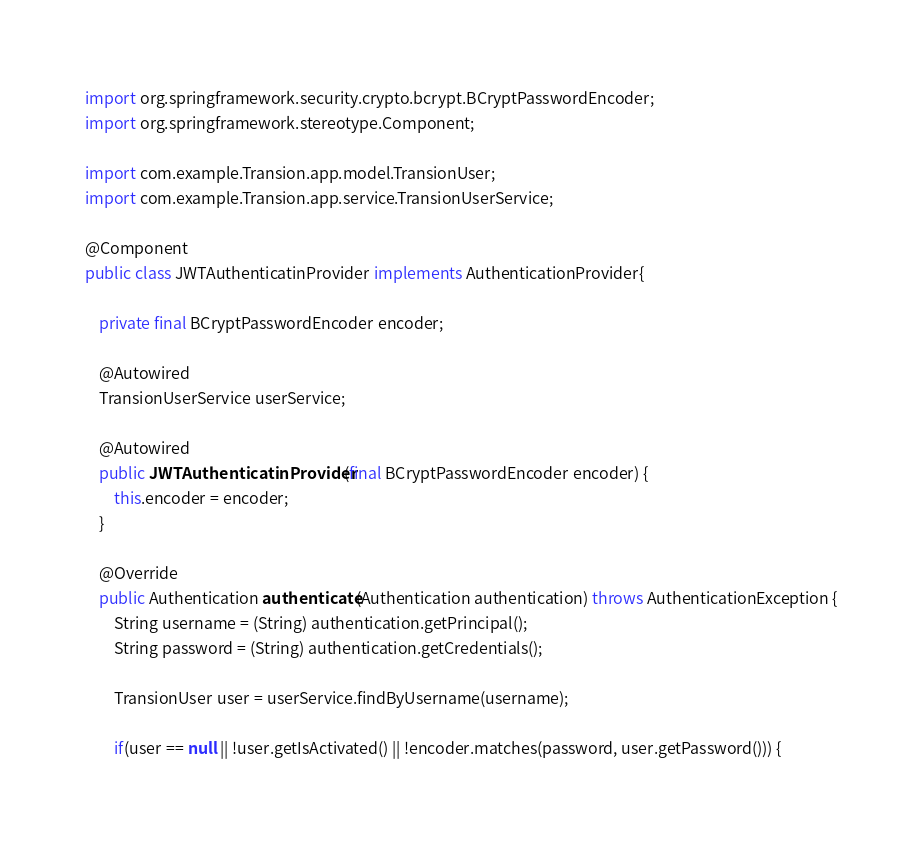<code> <loc_0><loc_0><loc_500><loc_500><_Java_>import org.springframework.security.crypto.bcrypt.BCryptPasswordEncoder;
import org.springframework.stereotype.Component;

import com.example.Transion.app.model.TransionUser;
import com.example.Transion.app.service.TransionUserService;

@Component
public class JWTAuthenticatinProvider implements AuthenticationProvider{

	private final BCryptPasswordEncoder encoder;
	
	@Autowired
	TransionUserService userService;
	
	@Autowired
    public JWTAuthenticatinProvider(final BCryptPasswordEncoder encoder) {
        this.encoder = encoder;
    }
	
	@Override
	public Authentication authenticate(Authentication authentication) throws AuthenticationException {
		String username = (String) authentication.getPrincipal();
        String password = (String) authentication.getCredentials();
        
        TransionUser user = userService.findByUsername(username);
        
        if(user == null || !user.getIsActivated() || !encoder.matches(password, user.getPassword())) {</code> 